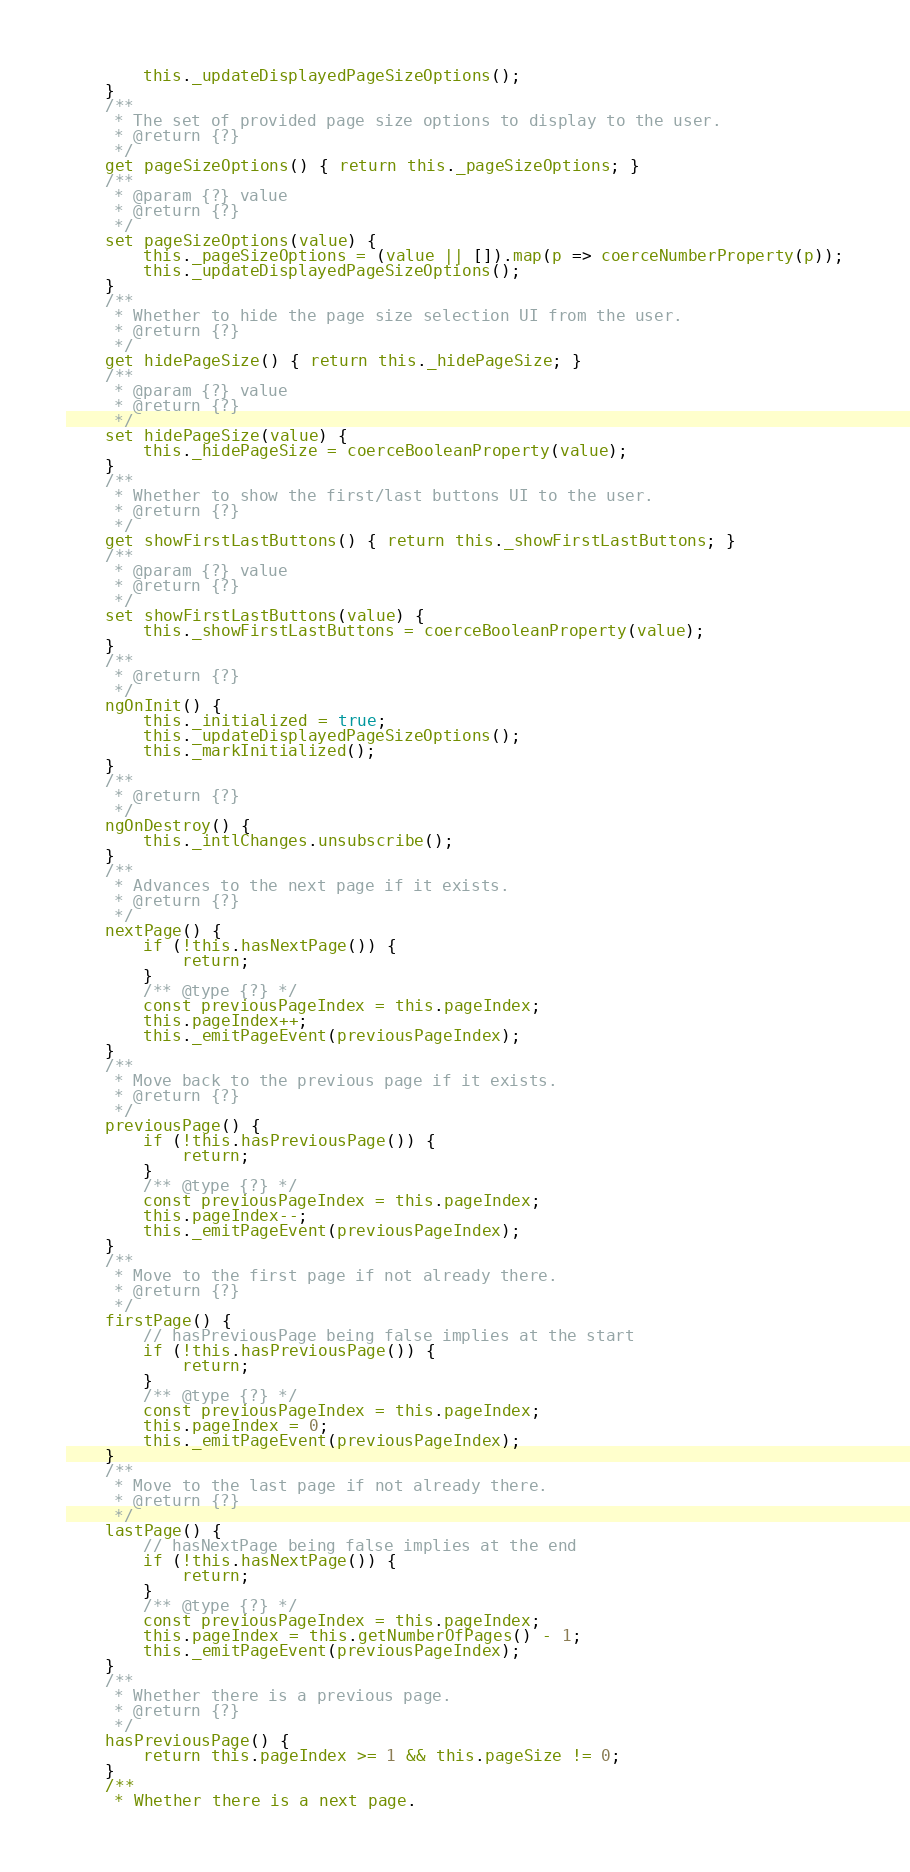Convert code to text. <code><loc_0><loc_0><loc_500><loc_500><_JavaScript_>        this._updateDisplayedPageSizeOptions();
    }
    /**
     * The set of provided page size options to display to the user.
     * @return {?}
     */
    get pageSizeOptions() { return this._pageSizeOptions; }
    /**
     * @param {?} value
     * @return {?}
     */
    set pageSizeOptions(value) {
        this._pageSizeOptions = (value || []).map(p => coerceNumberProperty(p));
        this._updateDisplayedPageSizeOptions();
    }
    /**
     * Whether to hide the page size selection UI from the user.
     * @return {?}
     */
    get hidePageSize() { return this._hidePageSize; }
    /**
     * @param {?} value
     * @return {?}
     */
    set hidePageSize(value) {
        this._hidePageSize = coerceBooleanProperty(value);
    }
    /**
     * Whether to show the first/last buttons UI to the user.
     * @return {?}
     */
    get showFirstLastButtons() { return this._showFirstLastButtons; }
    /**
     * @param {?} value
     * @return {?}
     */
    set showFirstLastButtons(value) {
        this._showFirstLastButtons = coerceBooleanProperty(value);
    }
    /**
     * @return {?}
     */
    ngOnInit() {
        this._initialized = true;
        this._updateDisplayedPageSizeOptions();
        this._markInitialized();
    }
    /**
     * @return {?}
     */
    ngOnDestroy() {
        this._intlChanges.unsubscribe();
    }
    /**
     * Advances to the next page if it exists.
     * @return {?}
     */
    nextPage() {
        if (!this.hasNextPage()) {
            return;
        }
        /** @type {?} */
        const previousPageIndex = this.pageIndex;
        this.pageIndex++;
        this._emitPageEvent(previousPageIndex);
    }
    /**
     * Move back to the previous page if it exists.
     * @return {?}
     */
    previousPage() {
        if (!this.hasPreviousPage()) {
            return;
        }
        /** @type {?} */
        const previousPageIndex = this.pageIndex;
        this.pageIndex--;
        this._emitPageEvent(previousPageIndex);
    }
    /**
     * Move to the first page if not already there.
     * @return {?}
     */
    firstPage() {
        // hasPreviousPage being false implies at the start
        if (!this.hasPreviousPage()) {
            return;
        }
        /** @type {?} */
        const previousPageIndex = this.pageIndex;
        this.pageIndex = 0;
        this._emitPageEvent(previousPageIndex);
    }
    /**
     * Move to the last page if not already there.
     * @return {?}
     */
    lastPage() {
        // hasNextPage being false implies at the end
        if (!this.hasNextPage()) {
            return;
        }
        /** @type {?} */
        const previousPageIndex = this.pageIndex;
        this.pageIndex = this.getNumberOfPages() - 1;
        this._emitPageEvent(previousPageIndex);
    }
    /**
     * Whether there is a previous page.
     * @return {?}
     */
    hasPreviousPage() {
        return this.pageIndex >= 1 && this.pageSize != 0;
    }
    /**
     * Whether there is a next page.</code> 